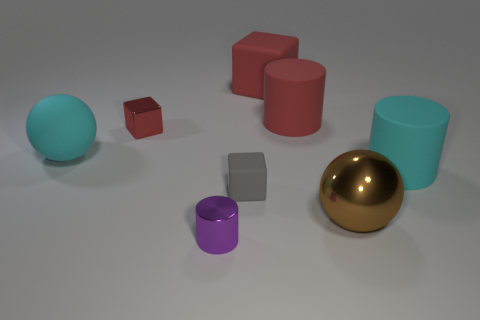Are there any patterns or alignments among the objects that you can describe? Yes, the objects are somewhat aligned in two rows, creating an orderly arrangement on the surface. The two spheres form a diagonal line, and there's a rough alignment of the cylinder, cube, and rectangular block. This layout gives an organized appearance to the collection of objects. Do you think there's any significance to the arrangement of the objects? The objects seem to be deliberately placed for a comparison of shapes, colors, and materials, perhaps for an artistic composition or a visual study in geometry and texture. The arrangement could be intended to showcase how light interacts differently with various surfaces and colors. 